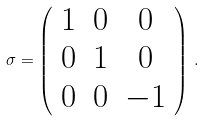Convert formula to latex. <formula><loc_0><loc_0><loc_500><loc_500>\sigma = \left ( \begin{array} { c c c } 1 & 0 & 0 \\ 0 & 1 & 0 \\ 0 & 0 & - 1 \end{array} \right ) \, .</formula> 